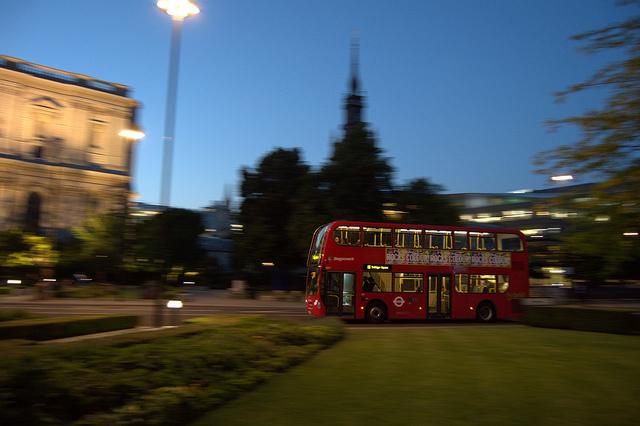What kind of bus is this?
Short answer required. Double decker. What number of stories is this bus?
Quick response, please. 2. Is the bus hungry?
Quick response, please. No. 